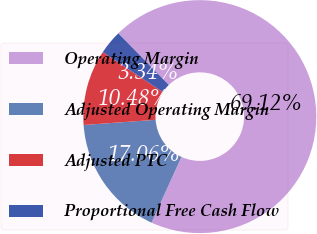<chart> <loc_0><loc_0><loc_500><loc_500><pie_chart><fcel>Operating Margin<fcel>Adjusted Operating Margin<fcel>Adjusted PTC<fcel>Proportional Free Cash Flow<nl><fcel>69.12%<fcel>17.06%<fcel>10.48%<fcel>3.34%<nl></chart> 